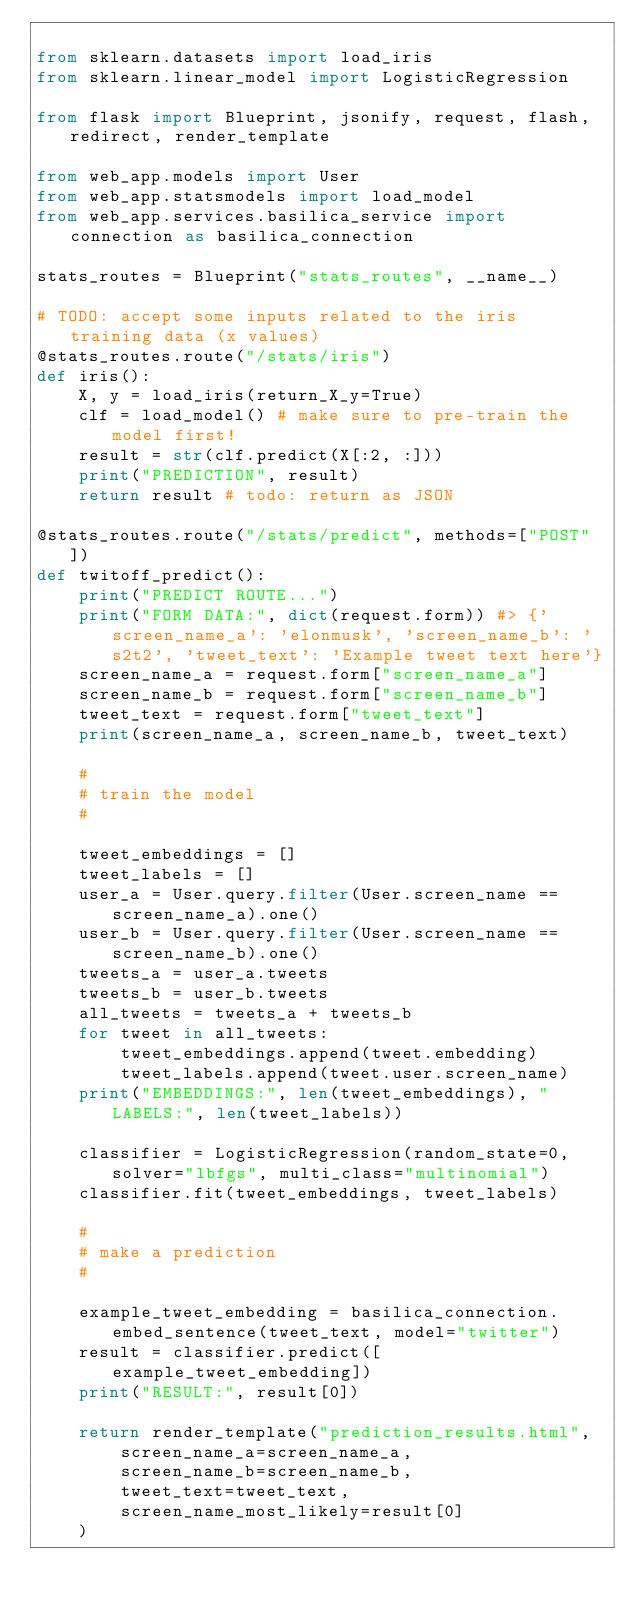<code> <loc_0><loc_0><loc_500><loc_500><_Python_>
from sklearn.datasets import load_iris
from sklearn.linear_model import LogisticRegression

from flask import Blueprint, jsonify, request, flash, redirect, render_template

from web_app.models import User
from web_app.statsmodels import load_model
from web_app.services.basilica_service import connection as basilica_connection

stats_routes = Blueprint("stats_routes", __name__)

# TODO: accept some inputs related to the iris training data (x values)
@stats_routes.route("/stats/iris")
def iris():
    X, y = load_iris(return_X_y=True)
    clf = load_model() # make sure to pre-train the model first!
    result = str(clf.predict(X[:2, :]))
    print("PREDICTION", result)
    return result # todo: return as JSON

@stats_routes.route("/stats/predict", methods=["POST"])
def twitoff_predict():
    print("PREDICT ROUTE...")
    print("FORM DATA:", dict(request.form)) #> {'screen_name_a': 'elonmusk', 'screen_name_b': 's2t2', 'tweet_text': 'Example tweet text here'}
    screen_name_a = request.form["screen_name_a"]
    screen_name_b = request.form["screen_name_b"]
    tweet_text = request.form["tweet_text"]
    print(screen_name_a, screen_name_b, tweet_text)

    #
    # train the model
    #

    tweet_embeddings = []
    tweet_labels = []
    user_a = User.query.filter(User.screen_name == screen_name_a).one()
    user_b = User.query.filter(User.screen_name == screen_name_b).one()
    tweets_a = user_a.tweets
    tweets_b = user_b.tweets
    all_tweets = tweets_a + tweets_b
    for tweet in all_tweets:
        tweet_embeddings.append(tweet.embedding)
        tweet_labels.append(tweet.user.screen_name)
    print("EMBEDDINGS:", len(tweet_embeddings), "LABELS:", len(tweet_labels))

    classifier = LogisticRegression(random_state=0, solver="lbfgs", multi_class="multinomial")
    classifier.fit(tweet_embeddings, tweet_labels)

    #
    # make a prediction
    #

    example_tweet_embedding = basilica_connection.embed_sentence(tweet_text, model="twitter")
    result = classifier.predict([example_tweet_embedding])
    print("RESULT:", result[0])

    return render_template("prediction_results.html",
        screen_name_a=screen_name_a,
        screen_name_b=screen_name_b,
        tweet_text=tweet_text,
        screen_name_most_likely=result[0]
    )</code> 